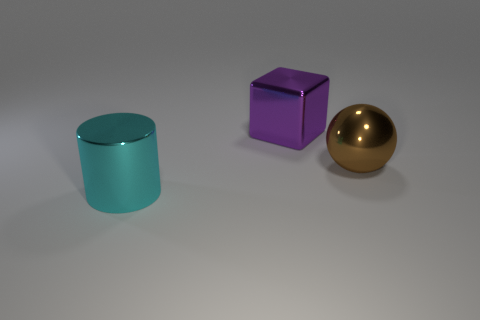Add 2 big yellow balls. How many objects exist? 5 Subtract all spheres. How many objects are left? 2 Subtract 1 brown balls. How many objects are left? 2 Subtract all large shiny balls. Subtract all large yellow shiny cubes. How many objects are left? 2 Add 1 purple objects. How many purple objects are left? 2 Add 1 yellow rubber cubes. How many yellow rubber cubes exist? 1 